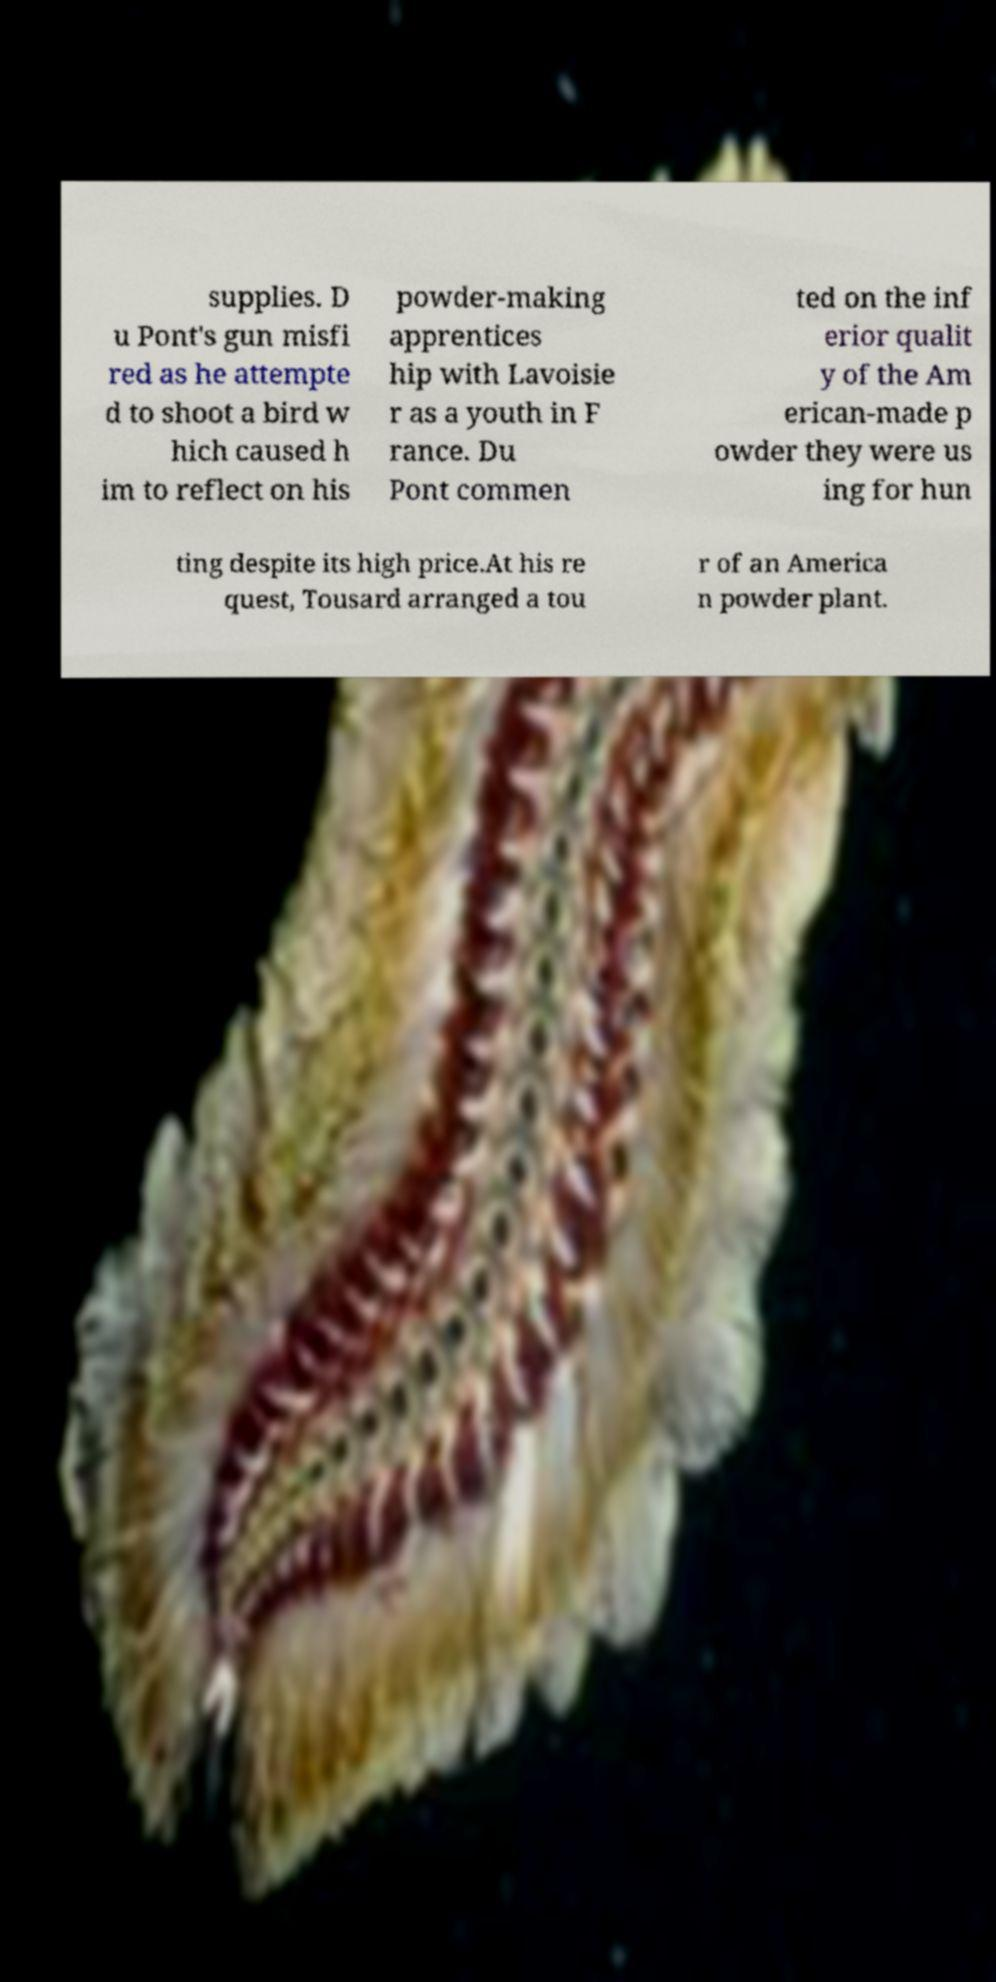Could you assist in decoding the text presented in this image and type it out clearly? supplies. D u Pont's gun misfi red as he attempte d to shoot a bird w hich caused h im to reflect on his powder-making apprentices hip with Lavoisie r as a youth in F rance. Du Pont commen ted on the inf erior qualit y of the Am erican-made p owder they were us ing for hun ting despite its high price.At his re quest, Tousard arranged a tou r of an America n powder plant. 